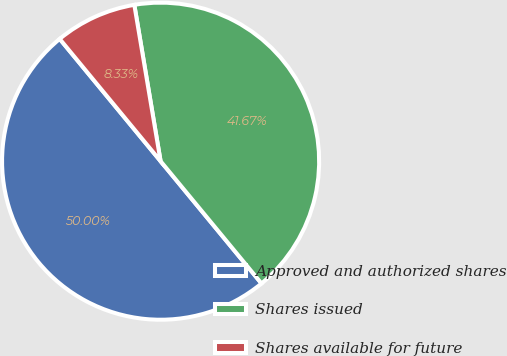<chart> <loc_0><loc_0><loc_500><loc_500><pie_chart><fcel>Approved and authorized shares<fcel>Shares issued<fcel>Shares available for future<nl><fcel>50.0%<fcel>41.67%<fcel>8.33%<nl></chart> 